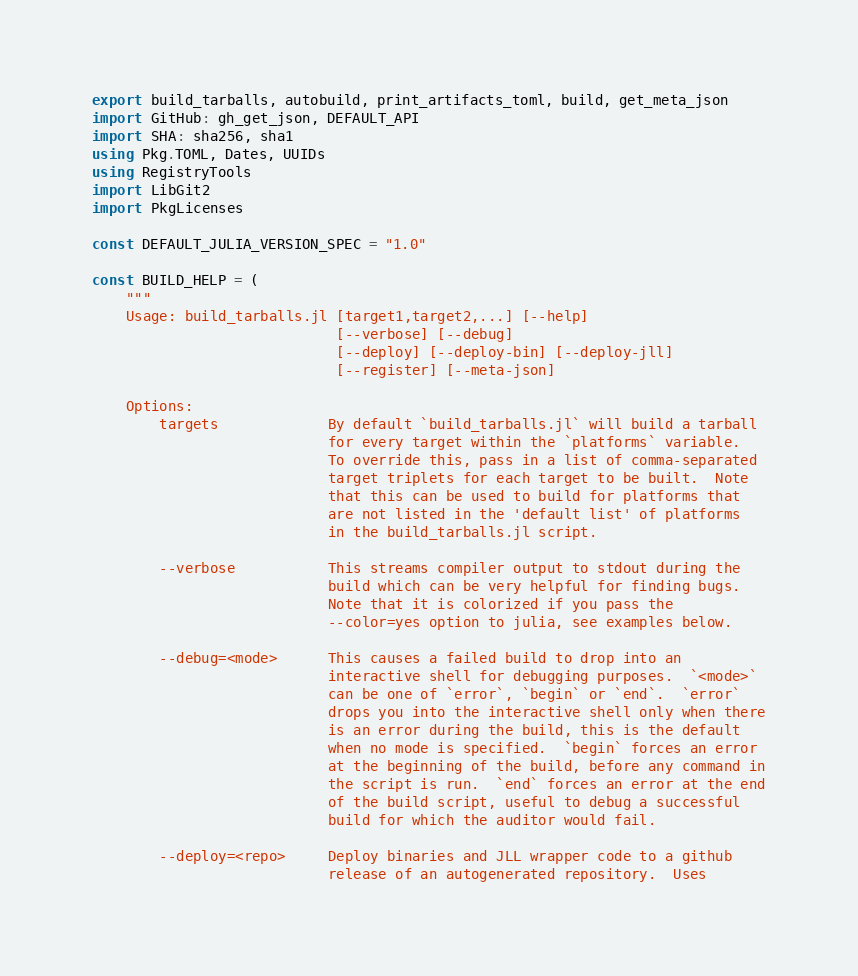<code> <loc_0><loc_0><loc_500><loc_500><_Julia_>export build_tarballs, autobuild, print_artifacts_toml, build, get_meta_json
import GitHub: gh_get_json, DEFAULT_API
import SHA: sha256, sha1
using Pkg.TOML, Dates, UUIDs
using RegistryTools
import LibGit2
import PkgLicenses

const DEFAULT_JULIA_VERSION_SPEC = "1.0"

const BUILD_HELP = (
    """
    Usage: build_tarballs.jl [target1,target2,...] [--help]
                             [--verbose] [--debug]
                             [--deploy] [--deploy-bin] [--deploy-jll]
                             [--register] [--meta-json]

    Options:
        targets             By default `build_tarballs.jl` will build a tarball
                            for every target within the `platforms` variable.
                            To override this, pass in a list of comma-separated
                            target triplets for each target to be built.  Note
                            that this can be used to build for platforms that
                            are not listed in the 'default list' of platforms
                            in the build_tarballs.jl script.

        --verbose           This streams compiler output to stdout during the
                            build which can be very helpful for finding bugs.
                            Note that it is colorized if you pass the
                            --color=yes option to julia, see examples below.

        --debug=<mode>      This causes a failed build to drop into an
                            interactive shell for debugging purposes.  `<mode>`
                            can be one of `error`, `begin` or `end`.  `error`
                            drops you into the interactive shell only when there
                            is an error during the build, this is the default
                            when no mode is specified.  `begin` forces an error
                            at the beginning of the build, before any command in
                            the script is run.  `end` forces an error at the end
                            of the build script, useful to debug a successful
                            build for which the auditor would fail.

        --deploy=<repo>     Deploy binaries and JLL wrapper code to a github
                            release of an autogenerated repository.  Uses</code> 